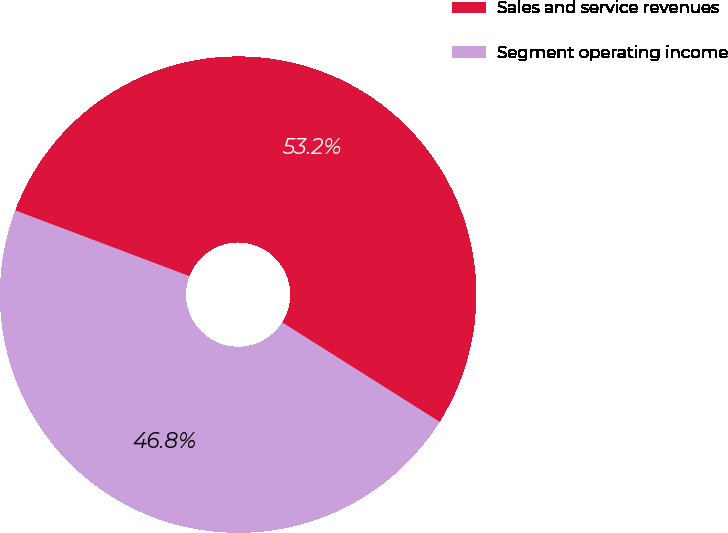Convert chart to OTSL. <chart><loc_0><loc_0><loc_500><loc_500><pie_chart><fcel>Sales and service revenues<fcel>Segment operating income<nl><fcel>53.22%<fcel>46.78%<nl></chart> 